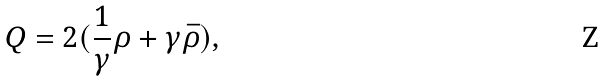<formula> <loc_0><loc_0><loc_500><loc_500>Q = 2 ( \frac { 1 } { \gamma } \rho + \gamma \bar { \rho } ) ,</formula> 